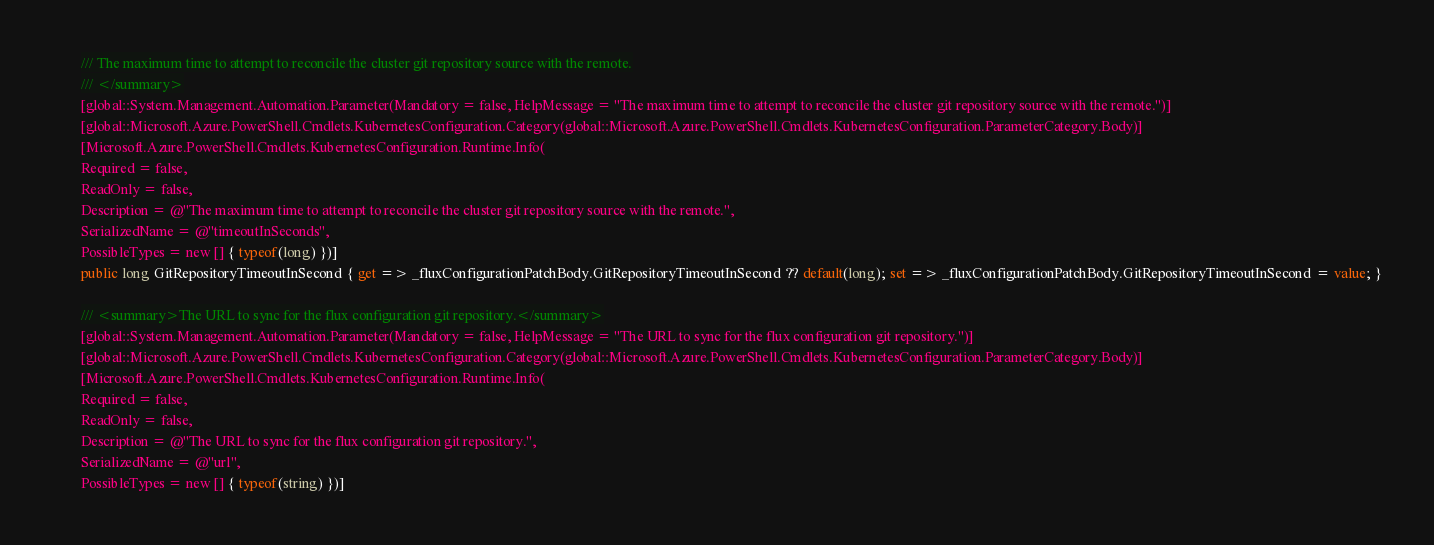<code> <loc_0><loc_0><loc_500><loc_500><_C#_>        /// The maximum time to attempt to reconcile the cluster git repository source with the remote.
        /// </summary>
        [global::System.Management.Automation.Parameter(Mandatory = false, HelpMessage = "The maximum time to attempt to reconcile the cluster git repository source with the remote.")]
        [global::Microsoft.Azure.PowerShell.Cmdlets.KubernetesConfiguration.Category(global::Microsoft.Azure.PowerShell.Cmdlets.KubernetesConfiguration.ParameterCategory.Body)]
        [Microsoft.Azure.PowerShell.Cmdlets.KubernetesConfiguration.Runtime.Info(
        Required = false,
        ReadOnly = false,
        Description = @"The maximum time to attempt to reconcile the cluster git repository source with the remote.",
        SerializedName = @"timeoutInSeconds",
        PossibleTypes = new [] { typeof(long) })]
        public long GitRepositoryTimeoutInSecond { get => _fluxConfigurationPatchBody.GitRepositoryTimeoutInSecond ?? default(long); set => _fluxConfigurationPatchBody.GitRepositoryTimeoutInSecond = value; }

        /// <summary>The URL to sync for the flux configuration git repository.</summary>
        [global::System.Management.Automation.Parameter(Mandatory = false, HelpMessage = "The URL to sync for the flux configuration git repository.")]
        [global::Microsoft.Azure.PowerShell.Cmdlets.KubernetesConfiguration.Category(global::Microsoft.Azure.PowerShell.Cmdlets.KubernetesConfiguration.ParameterCategory.Body)]
        [Microsoft.Azure.PowerShell.Cmdlets.KubernetesConfiguration.Runtime.Info(
        Required = false,
        ReadOnly = false,
        Description = @"The URL to sync for the flux configuration git repository.",
        SerializedName = @"url",
        PossibleTypes = new [] { typeof(string) })]</code> 